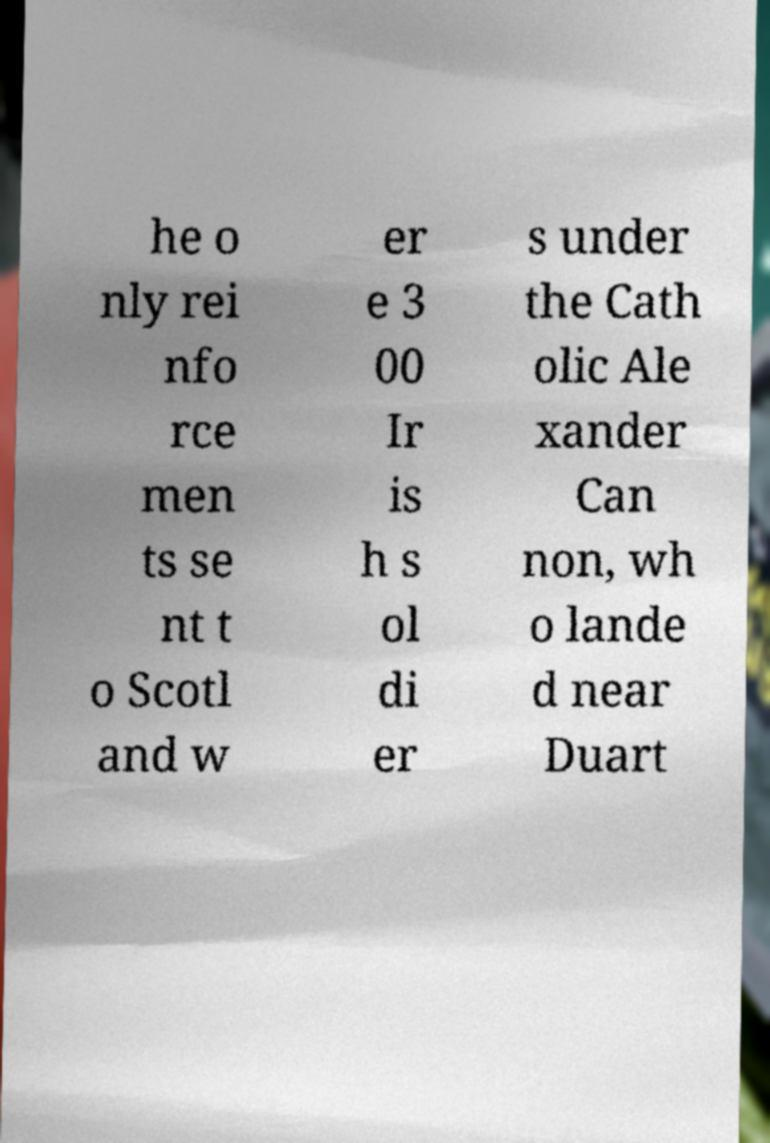Could you extract and type out the text from this image? he o nly rei nfo rce men ts se nt t o Scotl and w er e 3 00 Ir is h s ol di er s under the Cath olic Ale xander Can non, wh o lande d near Duart 